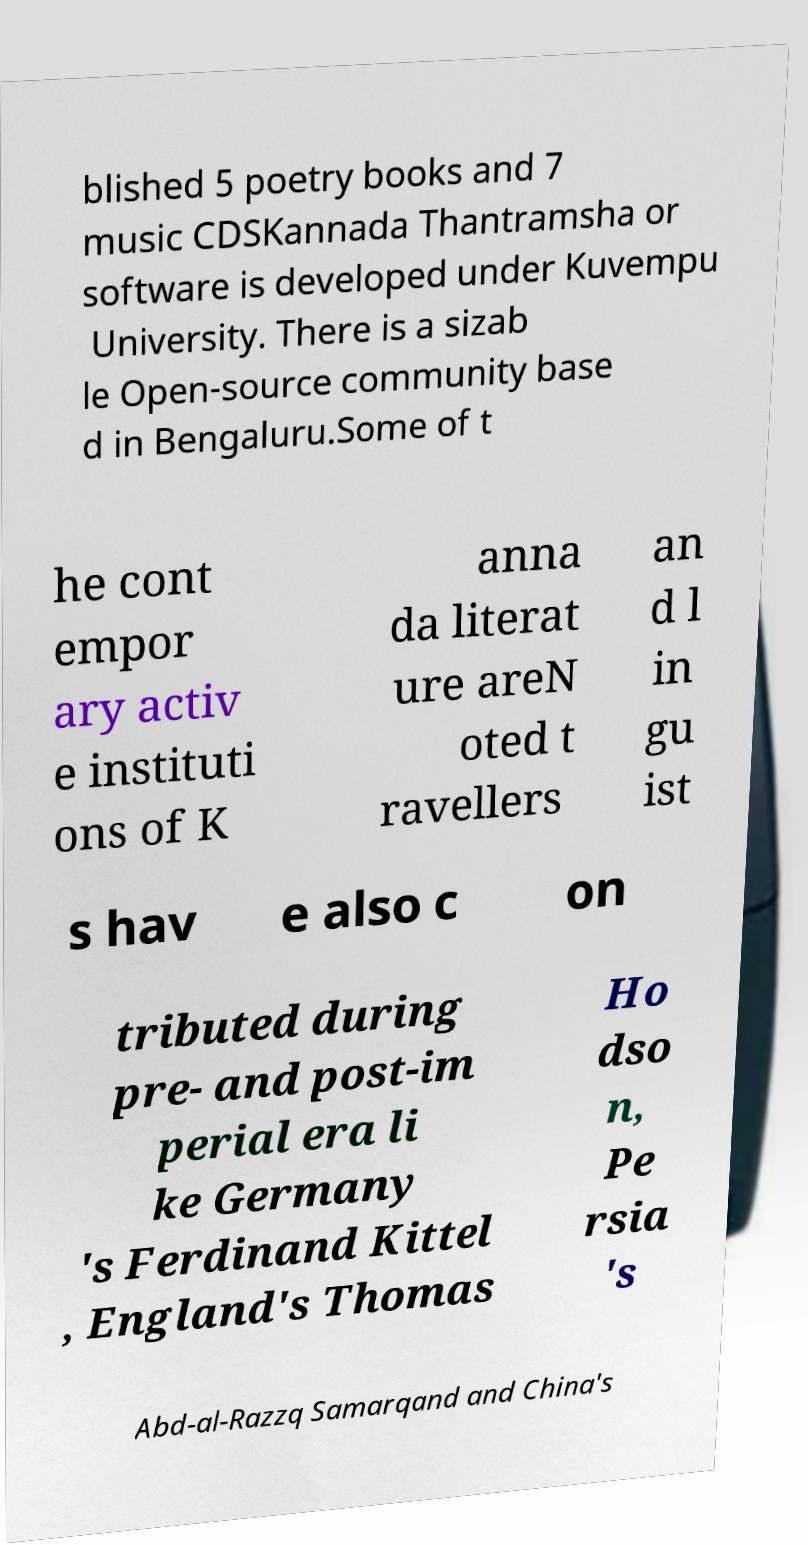Please identify and transcribe the text found in this image. blished 5 poetry books and 7 music CDSKannada Thantramsha or software is developed under Kuvempu University. There is a sizab le Open-source community base d in Bengaluru.Some of t he cont empor ary activ e instituti ons of K anna da literat ure areN oted t ravellers an d l in gu ist s hav e also c on tributed during pre- and post-im perial era li ke Germany 's Ferdinand Kittel , England's Thomas Ho dso n, Pe rsia 's Abd-al-Razzq Samarqand and China's 